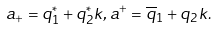<formula> <loc_0><loc_0><loc_500><loc_500>a _ { + } = q _ { 1 } ^ { \ast } + q _ { 2 } ^ { \ast } k , a ^ { + } = \overline { q } _ { 1 } + q _ { 2 } k .</formula> 